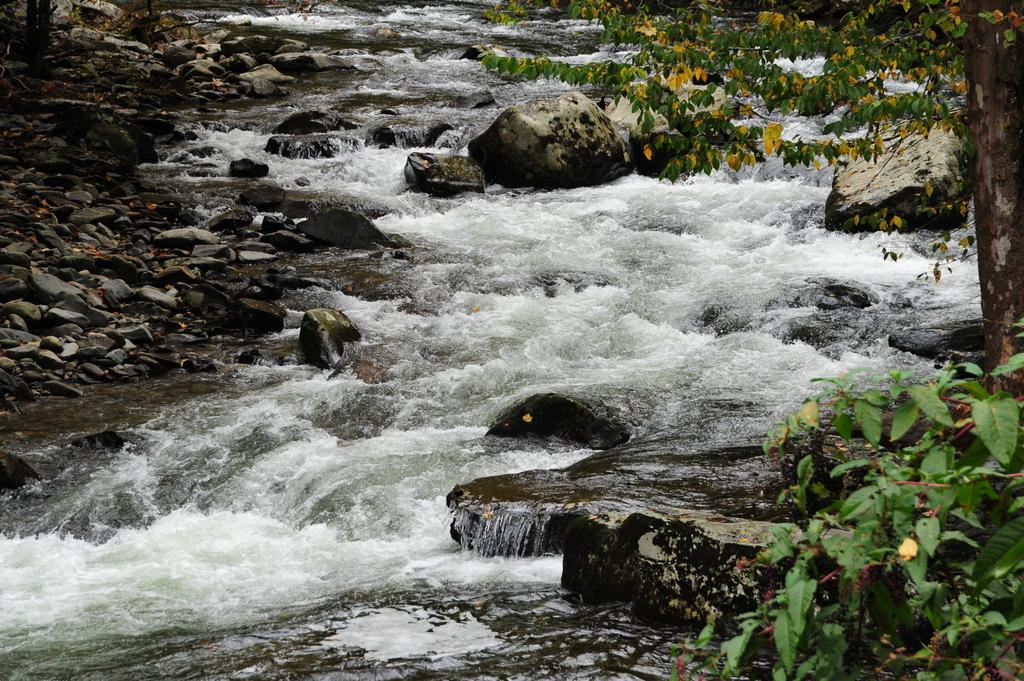What type of vegetation is on the right side of the image? There are trees on the right side of the image. What can be seen in the center of the image? There are stones and water flowing in the center of the image. What is present on the left side of the image? There are stones on the left side of the image. What type of fruit is hanging from the trees on the right side of the image? There is no fruit visible in the image; only trees are present on the right side. Can you tell me the rate at which the plane is flying in the image? There is no plane present in the image, so it is not possible to determine its flying rate. 